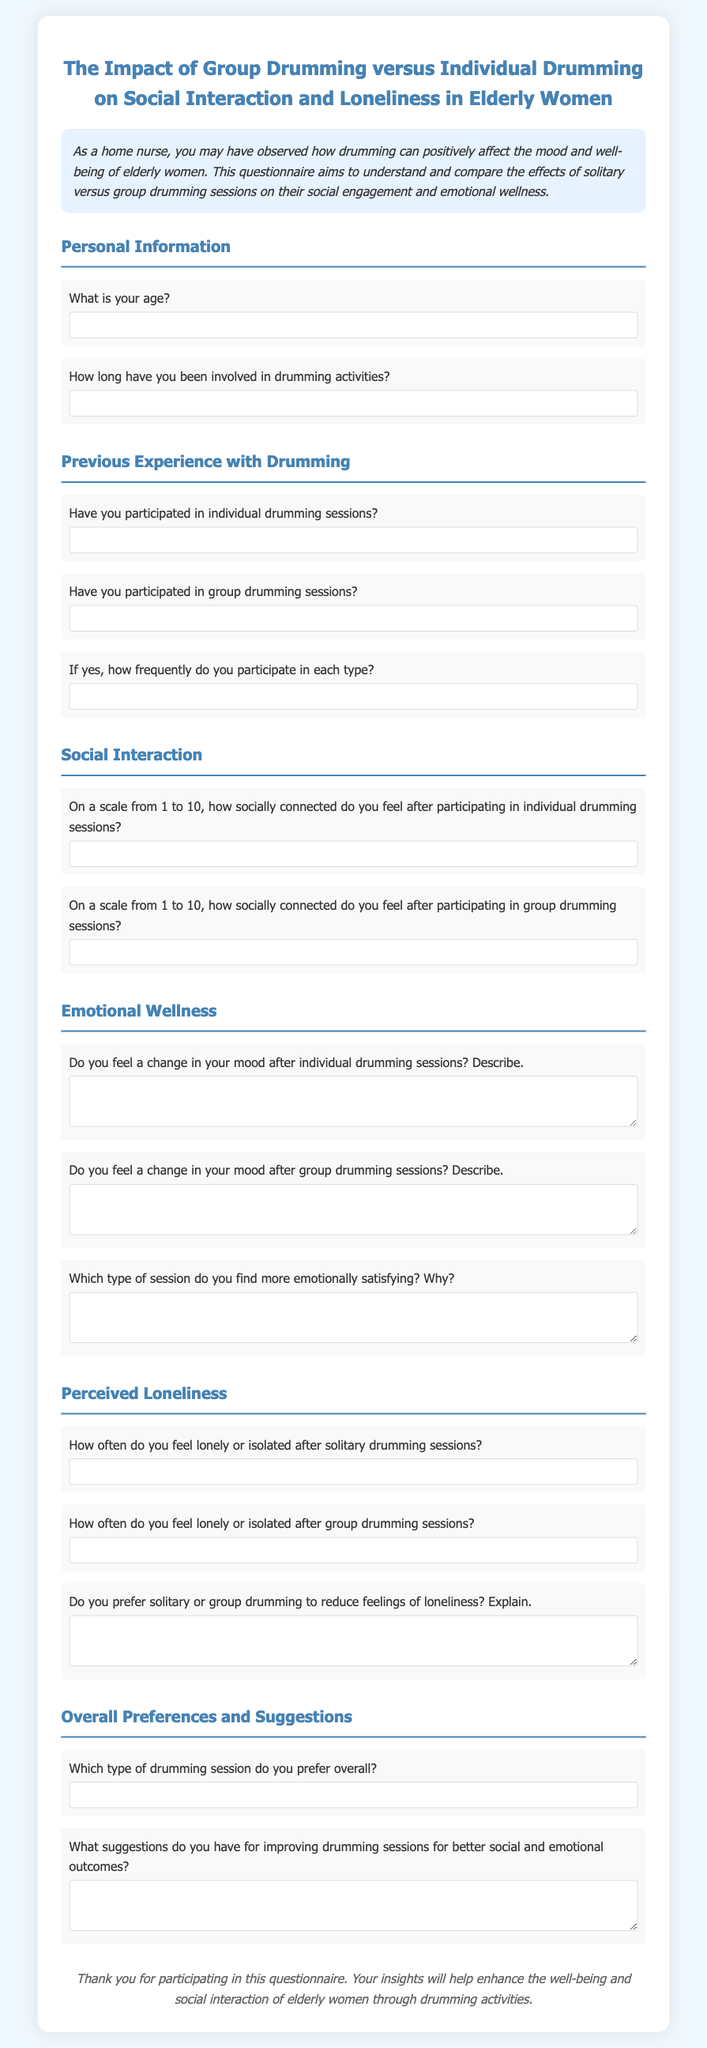What is the title of the questionnaire? The title is provided in the document for the questionnaire, which summarizes its purpose.
Answer: The Impact of Group Drumming versus Individual Drumming on Social Interaction and Loneliness in Elderly Women How many sections are in the questionnaire? The document is divided into sections which categorize the types of questions, such as personal information and emotional wellness.
Answer: Six What question asks about the frequency of drumming participation? This question is included in the section that discusses previous experience with drumming and looks for participation details.
Answer: If yes, how frequently do you participate in each type? On a scale from 1 to 10, which question allows respondents to rate their social connection after group drumming? The document prompts for a scale rating specifically for group drumming social connection.
Answer: On a scale from 1 to 10, how socially connected do you feel after participating in group drumming sessions? What type of session do participants find more emotionally satisfying? The questionnaire specifically asks for participants to compare emotional satisfaction across different types of sessions.
Answer: Which type of session do you find more emotionally satisfying? Why? How do respondents express their experiences after solitary drumming sessions? The document includes a question that explores feelings of loneliness or isolation following solitary drumming experiences.
Answer: How often do you feel lonely or isolated after solitary drumming sessions? 